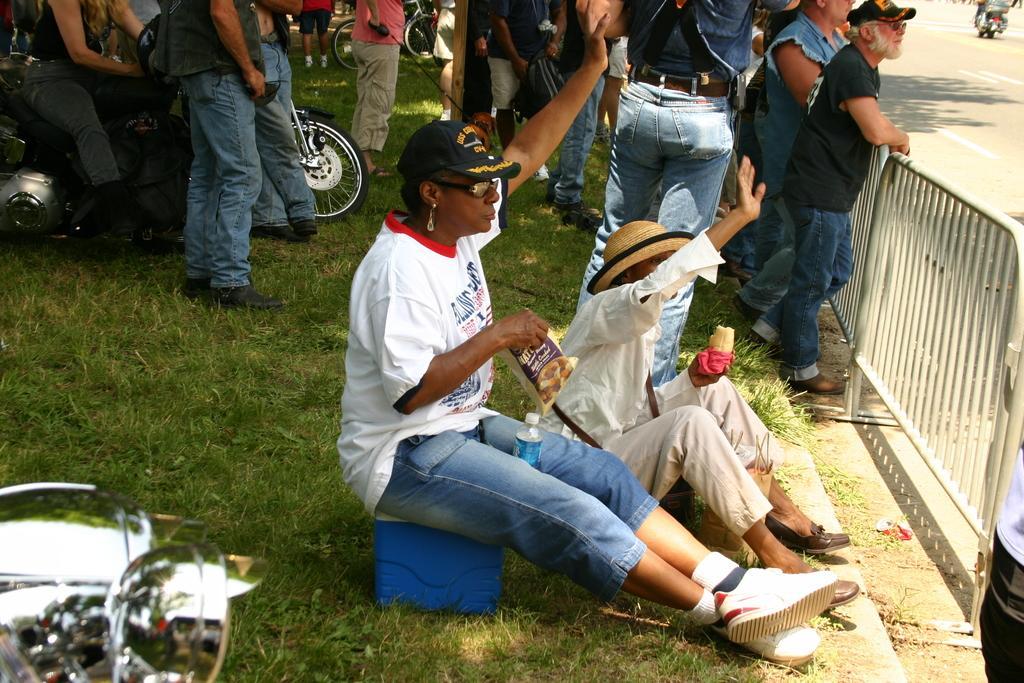In one or two sentences, can you explain what this image depicts? In this image a person is sitting on a basket. Few persons are standing on the grassland. Left side a person is sitting on the bike. Left bottom there is a bike. A person wearing a cap is sitting on the grass land. Few persons are standing near the fence. Right top a person is sitting on a bike and he is riding on the road. Top of the image there is a bicycle on the grassland. 